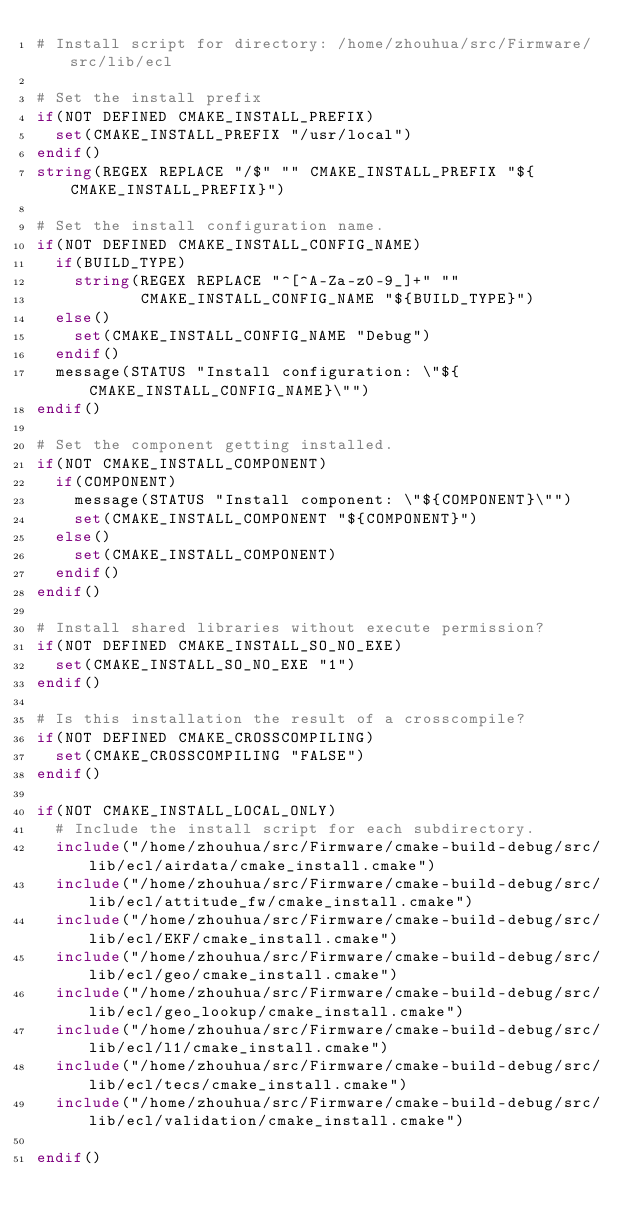Convert code to text. <code><loc_0><loc_0><loc_500><loc_500><_CMake_># Install script for directory: /home/zhouhua/src/Firmware/src/lib/ecl

# Set the install prefix
if(NOT DEFINED CMAKE_INSTALL_PREFIX)
  set(CMAKE_INSTALL_PREFIX "/usr/local")
endif()
string(REGEX REPLACE "/$" "" CMAKE_INSTALL_PREFIX "${CMAKE_INSTALL_PREFIX}")

# Set the install configuration name.
if(NOT DEFINED CMAKE_INSTALL_CONFIG_NAME)
  if(BUILD_TYPE)
    string(REGEX REPLACE "^[^A-Za-z0-9_]+" ""
           CMAKE_INSTALL_CONFIG_NAME "${BUILD_TYPE}")
  else()
    set(CMAKE_INSTALL_CONFIG_NAME "Debug")
  endif()
  message(STATUS "Install configuration: \"${CMAKE_INSTALL_CONFIG_NAME}\"")
endif()

# Set the component getting installed.
if(NOT CMAKE_INSTALL_COMPONENT)
  if(COMPONENT)
    message(STATUS "Install component: \"${COMPONENT}\"")
    set(CMAKE_INSTALL_COMPONENT "${COMPONENT}")
  else()
    set(CMAKE_INSTALL_COMPONENT)
  endif()
endif()

# Install shared libraries without execute permission?
if(NOT DEFINED CMAKE_INSTALL_SO_NO_EXE)
  set(CMAKE_INSTALL_SO_NO_EXE "1")
endif()

# Is this installation the result of a crosscompile?
if(NOT DEFINED CMAKE_CROSSCOMPILING)
  set(CMAKE_CROSSCOMPILING "FALSE")
endif()

if(NOT CMAKE_INSTALL_LOCAL_ONLY)
  # Include the install script for each subdirectory.
  include("/home/zhouhua/src/Firmware/cmake-build-debug/src/lib/ecl/airdata/cmake_install.cmake")
  include("/home/zhouhua/src/Firmware/cmake-build-debug/src/lib/ecl/attitude_fw/cmake_install.cmake")
  include("/home/zhouhua/src/Firmware/cmake-build-debug/src/lib/ecl/EKF/cmake_install.cmake")
  include("/home/zhouhua/src/Firmware/cmake-build-debug/src/lib/ecl/geo/cmake_install.cmake")
  include("/home/zhouhua/src/Firmware/cmake-build-debug/src/lib/ecl/geo_lookup/cmake_install.cmake")
  include("/home/zhouhua/src/Firmware/cmake-build-debug/src/lib/ecl/l1/cmake_install.cmake")
  include("/home/zhouhua/src/Firmware/cmake-build-debug/src/lib/ecl/tecs/cmake_install.cmake")
  include("/home/zhouhua/src/Firmware/cmake-build-debug/src/lib/ecl/validation/cmake_install.cmake")

endif()

</code> 